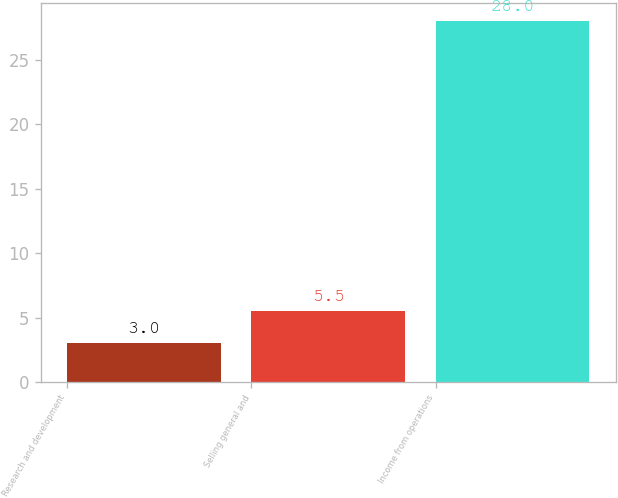<chart> <loc_0><loc_0><loc_500><loc_500><bar_chart><fcel>Research and development<fcel>Selling general and<fcel>Income from operations<nl><fcel>3<fcel>5.5<fcel>28<nl></chart> 